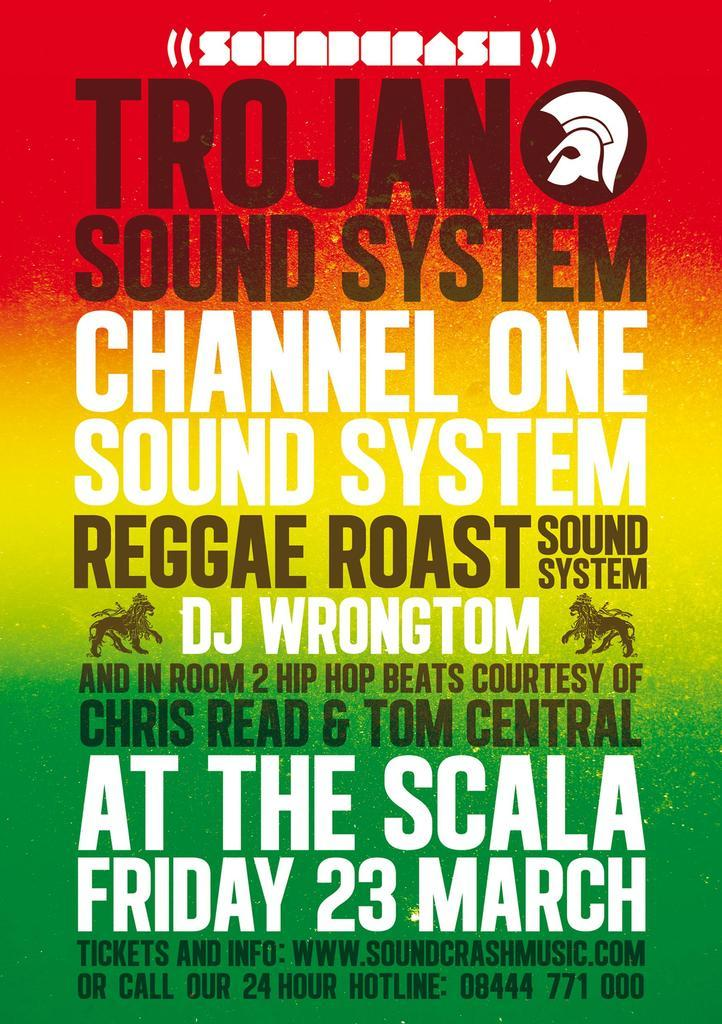Provide a one-sentence caption for the provided image. Concert poster for Trojan Sound System and others. 